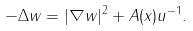<formula> <loc_0><loc_0><loc_500><loc_500>- \Delta w = | \nabla w | ^ { 2 } + A ( x ) u ^ { - 1 } .</formula> 